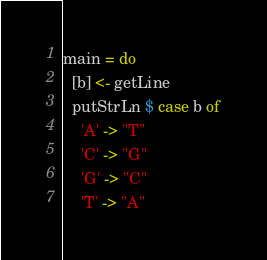Convert code to text. <code><loc_0><loc_0><loc_500><loc_500><_Haskell_>main = do
  [b] <- getLine
  putStrLn $ case b of
    'A' -> "T"
    'C' -> "G"
    'G' -> "C"
    'T' -> "A"
</code> 